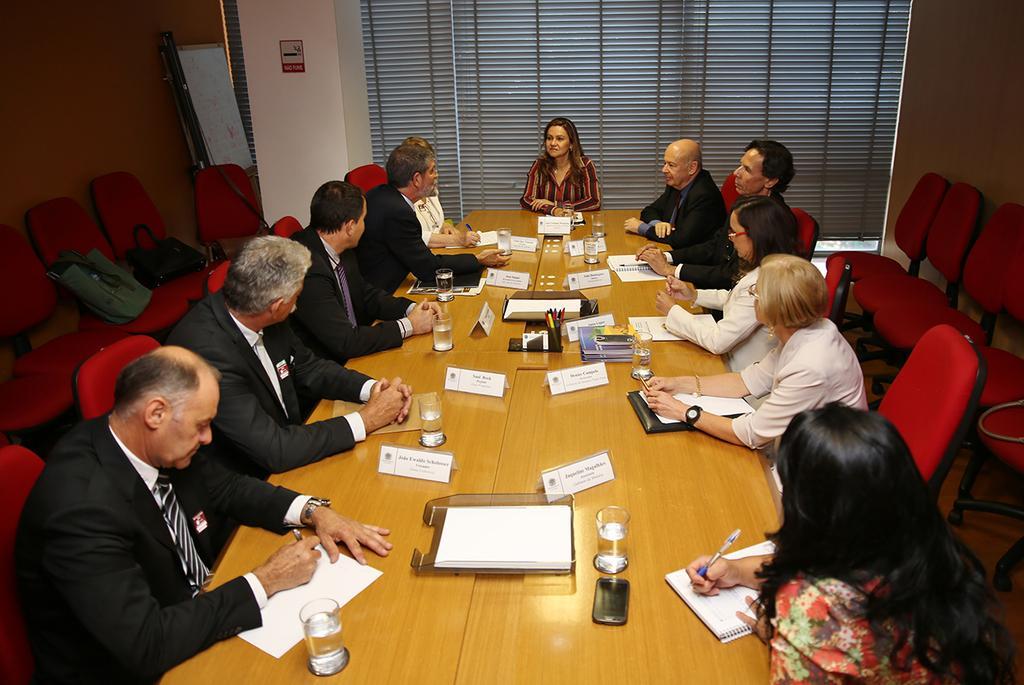Describe this image in one or two sentences. In this image there are group of people who are sitting on a chairs in front of them there is one table on that table there are some papers, glasses and name plates and pins are there and on the top there is a window. On the left side there is a wall and some chairs are there. 